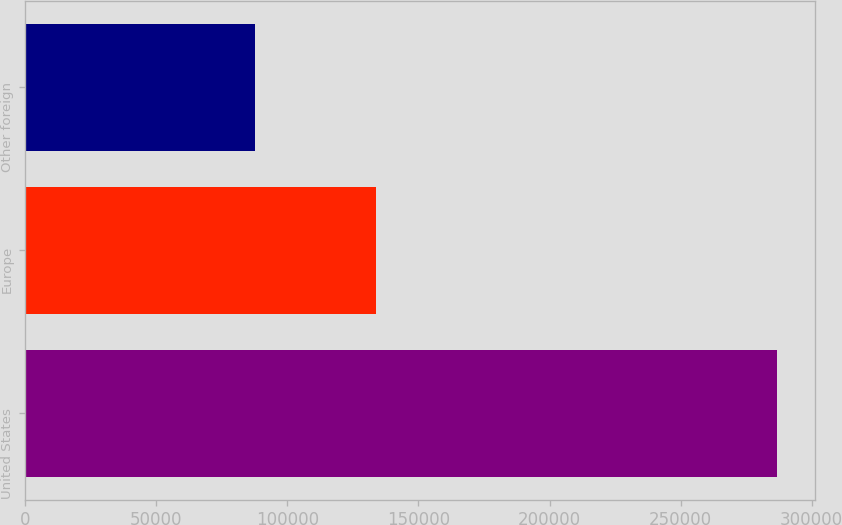<chart> <loc_0><loc_0><loc_500><loc_500><bar_chart><fcel>United States<fcel>Europe<fcel>Other foreign<nl><fcel>286879<fcel>133877<fcel>87805<nl></chart> 